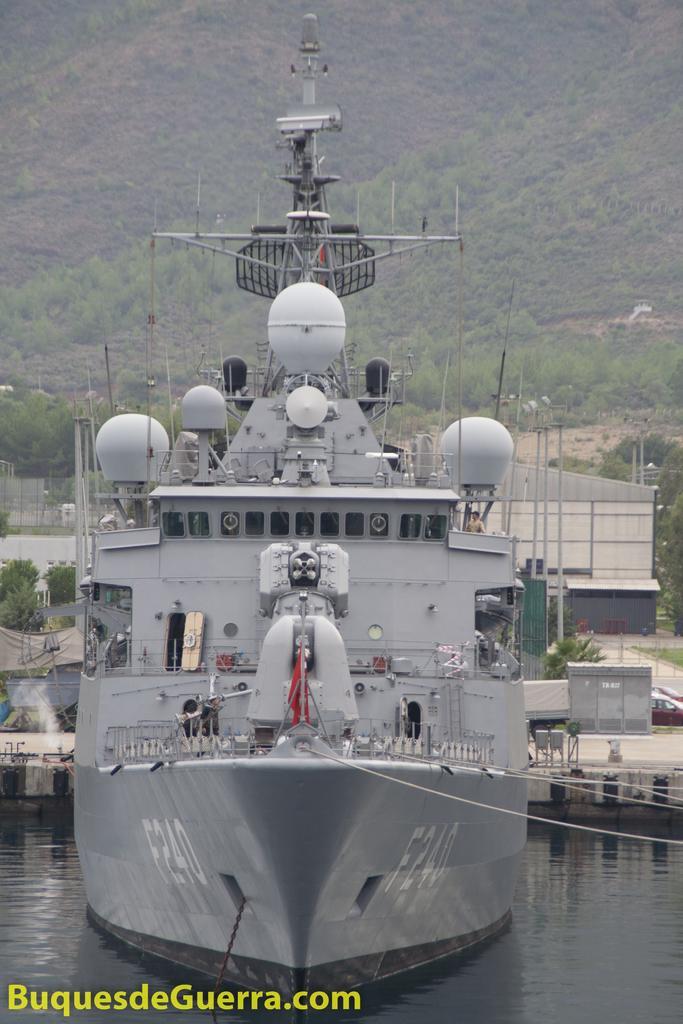Could you give a brief overview of what you see in this image? In this picture I can see a war ship on the water, there are vehicles, buildings, and in the background there are trees and there is a watermark on the image. 